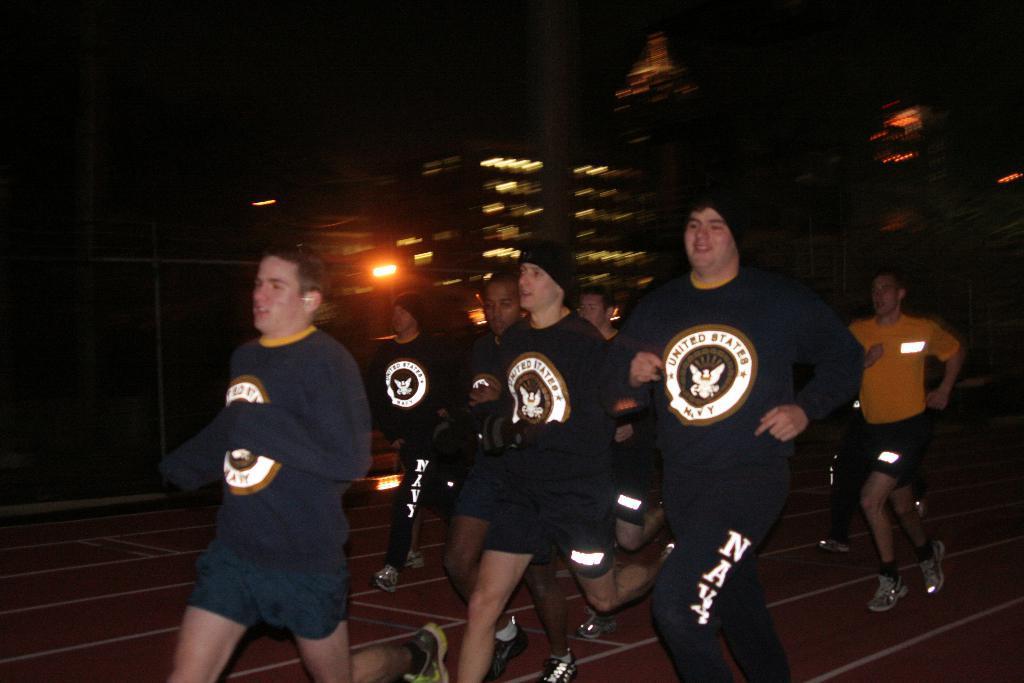Please provide a concise description of this image. In this image, I can see a group of people running. In the background there are buildings and lights. 